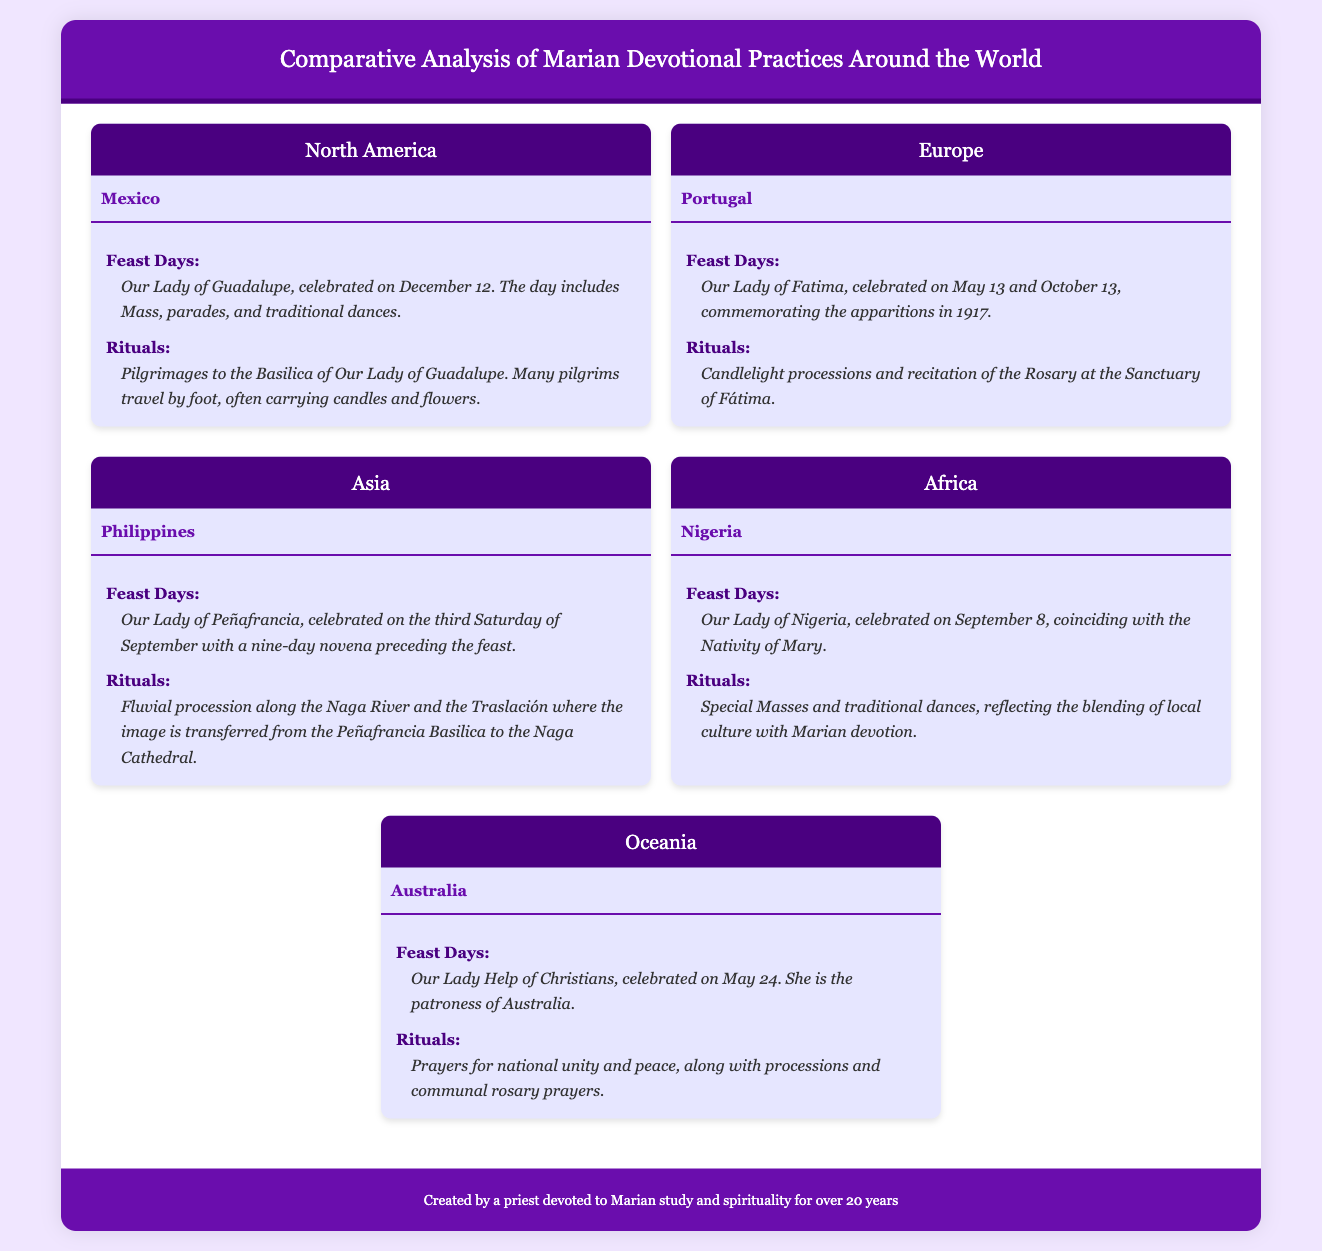what is the feast day celebrated in Mexico? The feast day celebrated in Mexico is Our Lady of Guadalupe, which is observed on December 12.
Answer: Our Lady of Guadalupe, December 12 which country celebrates Our Lady of Fatima? Our Lady of Fatima is celebrated in Portugal on May 13 and October 13.
Answer: Portugal what unique ritual is performed during the celebration of Our Lady of Peñafrancia in the Philippines? A unique ritual in the Philippines is the Fluvial procession along the Naga River.
Answer: Fluvial procession how is the feast of Our Lady of Nigeria observed? The feast of Our Lady of Nigeria includes special Masses and traditional dances.
Answer: Special Masses and traditional dances which Marian devotion is recognized as the patroness of Australia? Our Lady Help of Christians is recognized as the patroness of Australia.
Answer: Our Lady Help of Christians what is a common element found in the rituals of both Nigeria and Mexico? Both countries incorporate traditional dances into their Marian celebrations.
Answer: Traditional dances how many days of novena precede the feast of Our Lady of Peñafrancia? The novena preceding the feast of Our Lady of Peñafrancia lasts for nine days.
Answer: Nine days on what date is Our Lady Help of Christians celebrated in Australia? Our Lady Help of Christians is celebrated on May 24.
Answer: May 24 